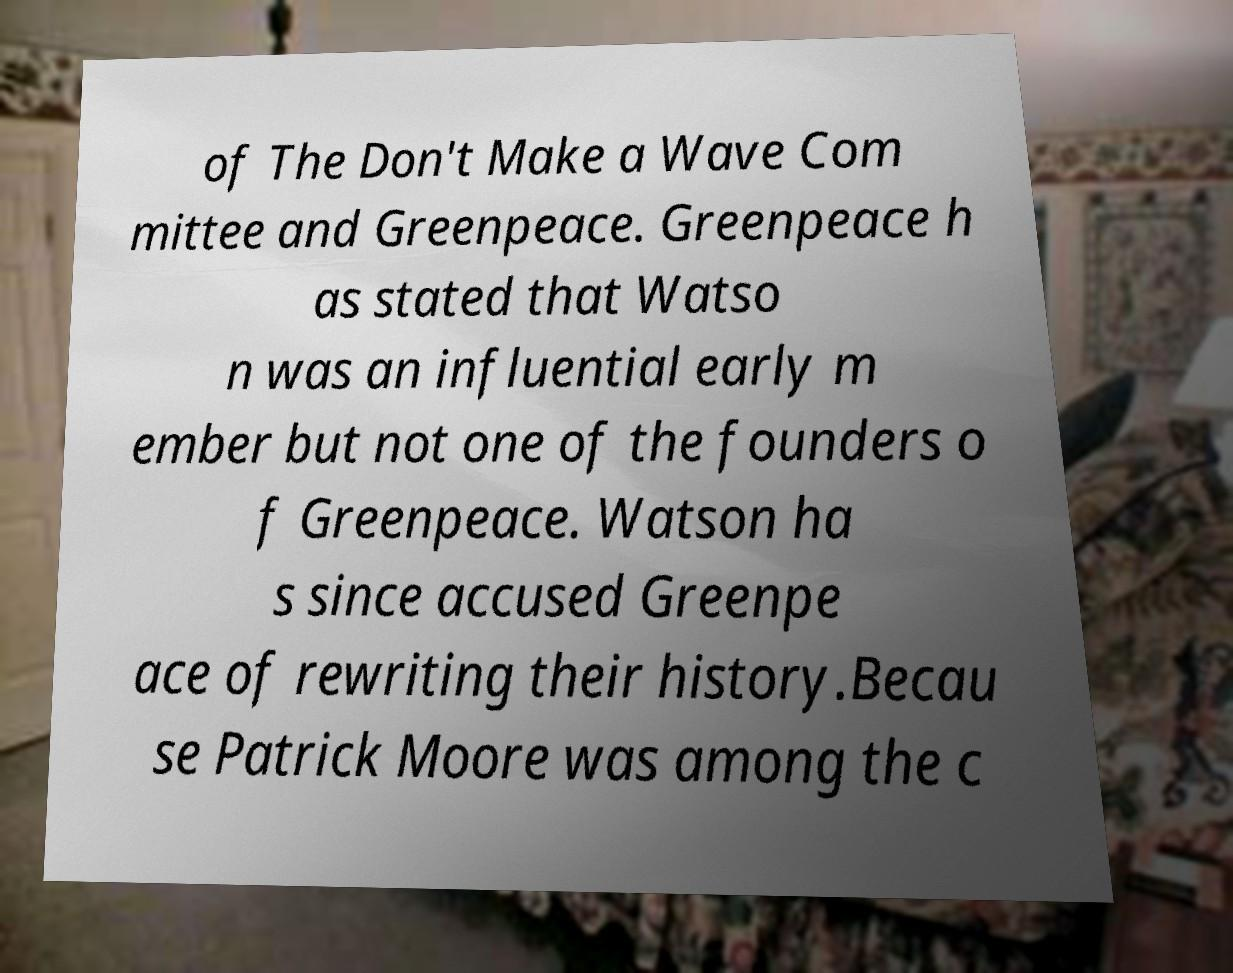I need the written content from this picture converted into text. Can you do that? of The Don't Make a Wave Com mittee and Greenpeace. Greenpeace h as stated that Watso n was an influential early m ember but not one of the founders o f Greenpeace. Watson ha s since accused Greenpe ace of rewriting their history.Becau se Patrick Moore was among the c 